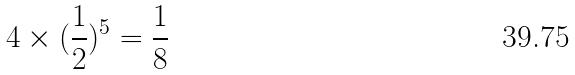Convert formula to latex. <formula><loc_0><loc_0><loc_500><loc_500>4 \times ( \frac { 1 } { 2 } ) ^ { 5 } = \frac { 1 } { 8 }</formula> 